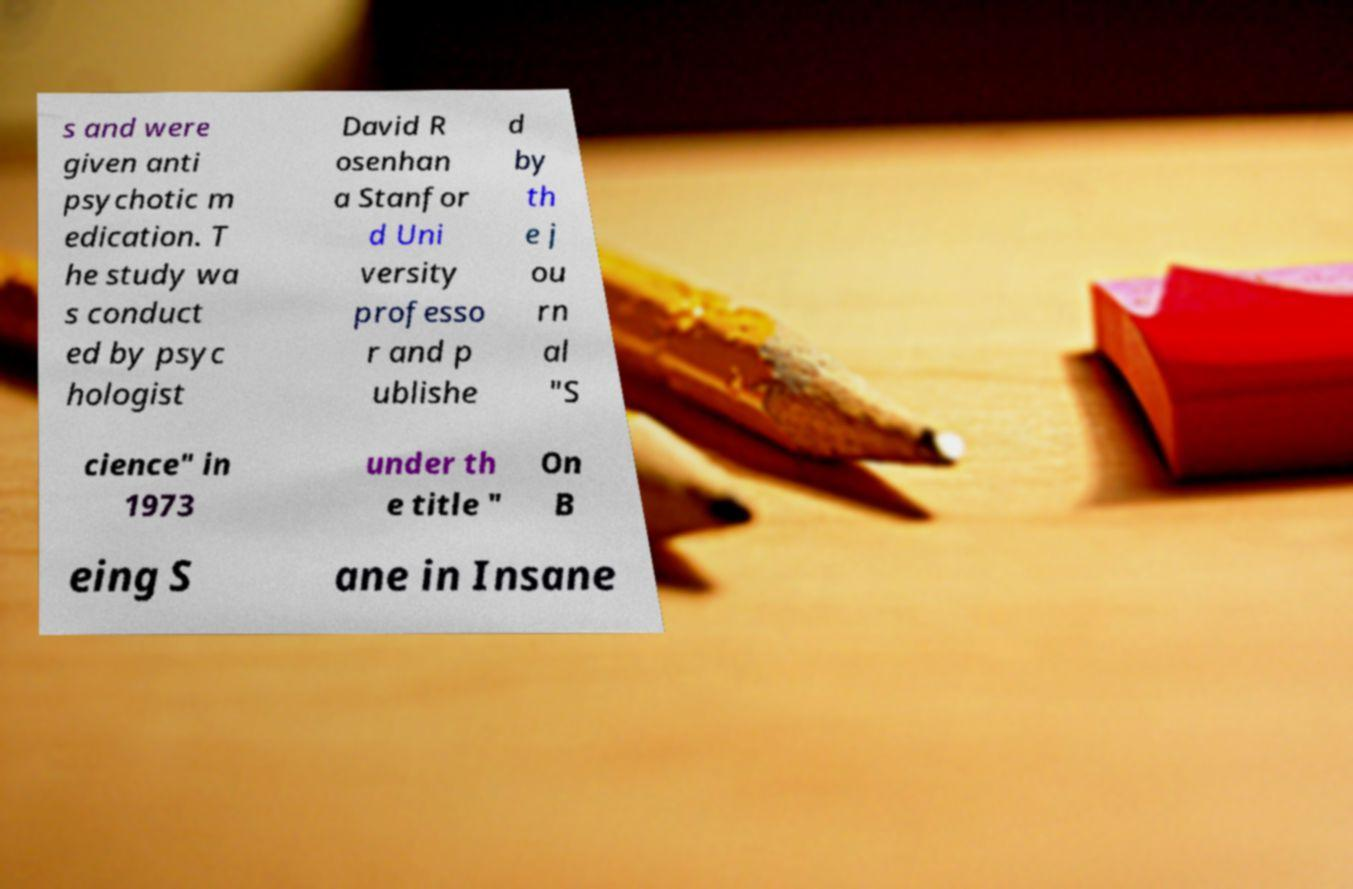Can you read and provide the text displayed in the image?This photo seems to have some interesting text. Can you extract and type it out for me? s and were given anti psychotic m edication. T he study wa s conduct ed by psyc hologist David R osenhan a Stanfor d Uni versity professo r and p ublishe d by th e j ou rn al "S cience" in 1973 under th e title " On B eing S ane in Insane 